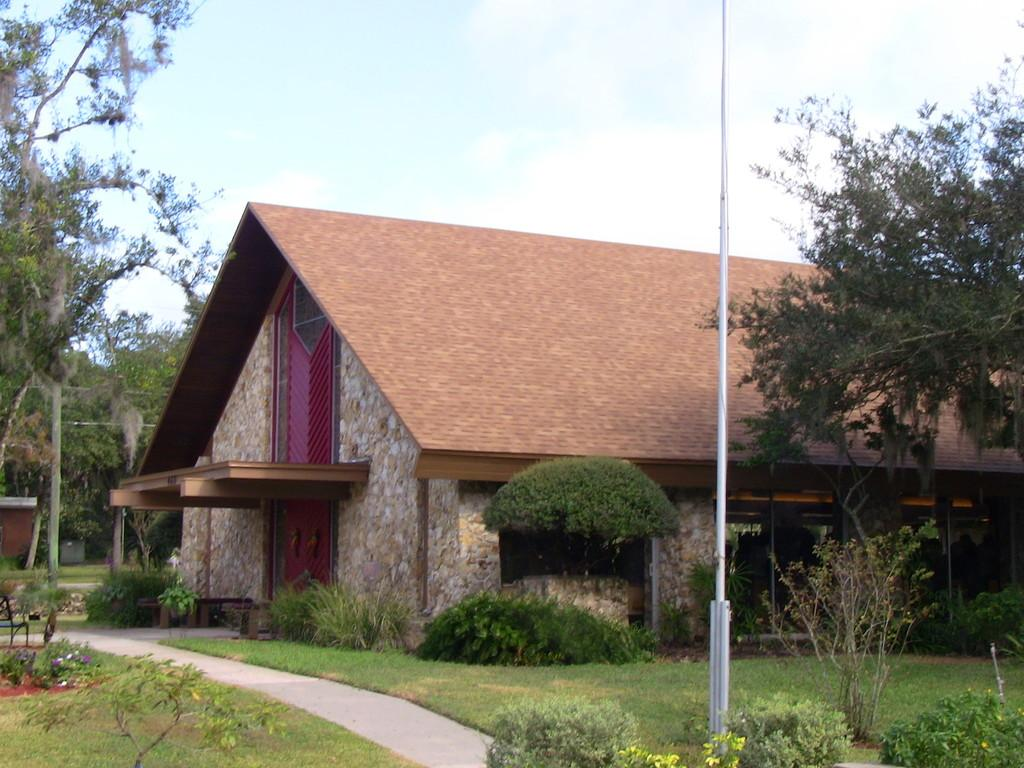What is visible in the sky in the image? The sky with clouds is visible in the image. What object can be seen in the image that is typically used for supporting or attaching items? There is a pole in the image. What type of vegetation can be seen in the image? There are trees, plants, bushes, and shrubs visible in the image. What part of the natural environment is visible in the image? The ground is visible in the image. What type of structure can be seen in the image? There is a building in the image. What type of sun is visible in the image? There is no sun visible in the image; only clouds are present in the sky. What type of system is responsible for the growth of the plants in the image? The image does not provide information about the system responsible for the growth of the plants. 